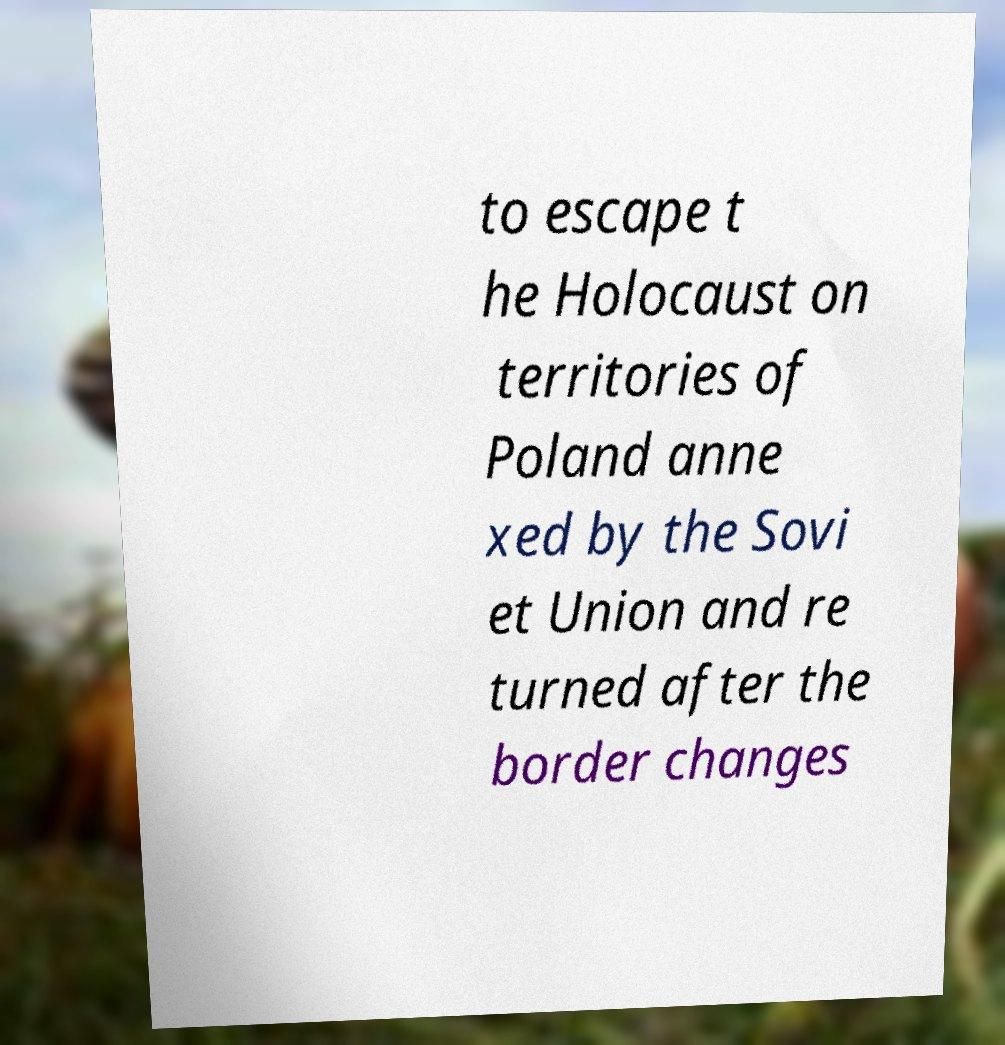For documentation purposes, I need the text within this image transcribed. Could you provide that? to escape t he Holocaust on territories of Poland anne xed by the Sovi et Union and re turned after the border changes 